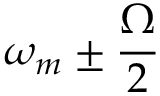<formula> <loc_0><loc_0><loc_500><loc_500>\omega _ { m } \pm \frac { \Omega } { 2 }</formula> 